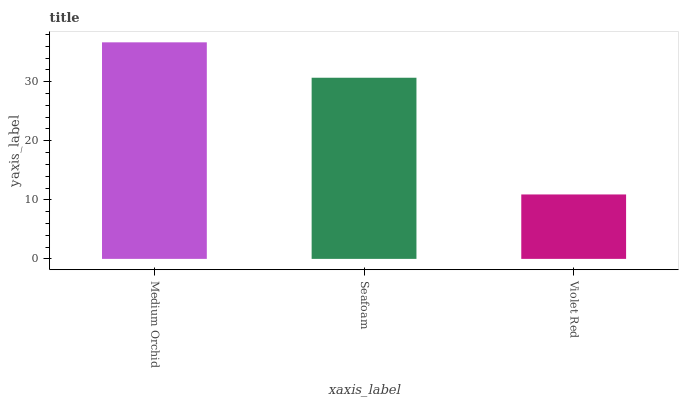Is Violet Red the minimum?
Answer yes or no. Yes. Is Medium Orchid the maximum?
Answer yes or no. Yes. Is Seafoam the minimum?
Answer yes or no. No. Is Seafoam the maximum?
Answer yes or no. No. Is Medium Orchid greater than Seafoam?
Answer yes or no. Yes. Is Seafoam less than Medium Orchid?
Answer yes or no. Yes. Is Seafoam greater than Medium Orchid?
Answer yes or no. No. Is Medium Orchid less than Seafoam?
Answer yes or no. No. Is Seafoam the high median?
Answer yes or no. Yes. Is Seafoam the low median?
Answer yes or no. Yes. Is Medium Orchid the high median?
Answer yes or no. No. Is Violet Red the low median?
Answer yes or no. No. 